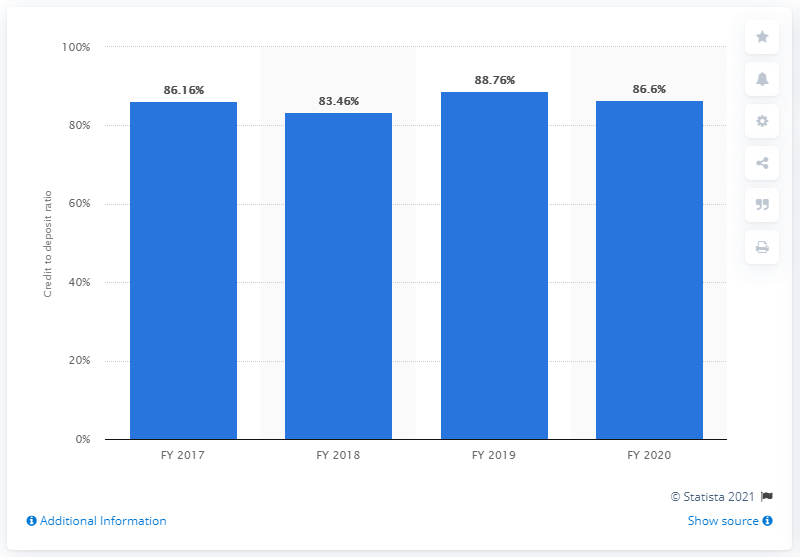Point out several critical features in this image. In the fiscal year 2020, the CD (deposit to credit) ratio of private sector banks in India was 88.76, which indicates that for every 100 rupees deposited by customers, the banks lent out 88.76 rupees in the form of loans. This is a significant figure as it reflects the level of liquidity and the willingness of banks to lend to customers. 